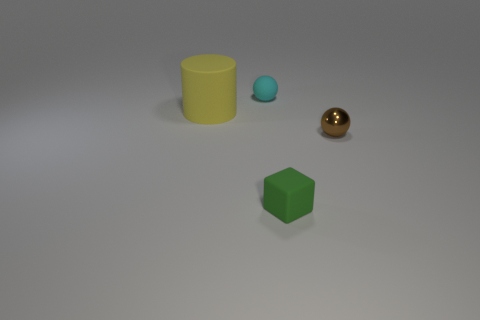Are there any other things that are the same size as the rubber cylinder?
Provide a short and direct response. No. There is a tiny thing in front of the tiny sphere that is on the right side of the object behind the yellow rubber thing; what is its material?
Keep it short and to the point. Rubber. The rubber thing that is left of the tiny ball behind the tiny sphere on the right side of the green cube is what shape?
Offer a very short reply. Cylinder. Are there any other things that are the same material as the brown sphere?
Give a very brief answer. No. There is a cyan rubber object that is the same shape as the metallic object; what is its size?
Your response must be concise. Small. There is a thing that is both right of the large yellow cylinder and on the left side of the tiny green thing; what is its color?
Provide a succinct answer. Cyan. Are the tiny cyan object and the object that is to the left of the matte sphere made of the same material?
Keep it short and to the point. Yes. Are there fewer brown balls behind the small shiny thing than brown spheres?
Provide a short and direct response. Yes. What number of other things are the same shape as the small metallic thing?
Offer a terse response. 1. How many other objects are there of the same size as the cyan rubber object?
Ensure brevity in your answer.  2. 